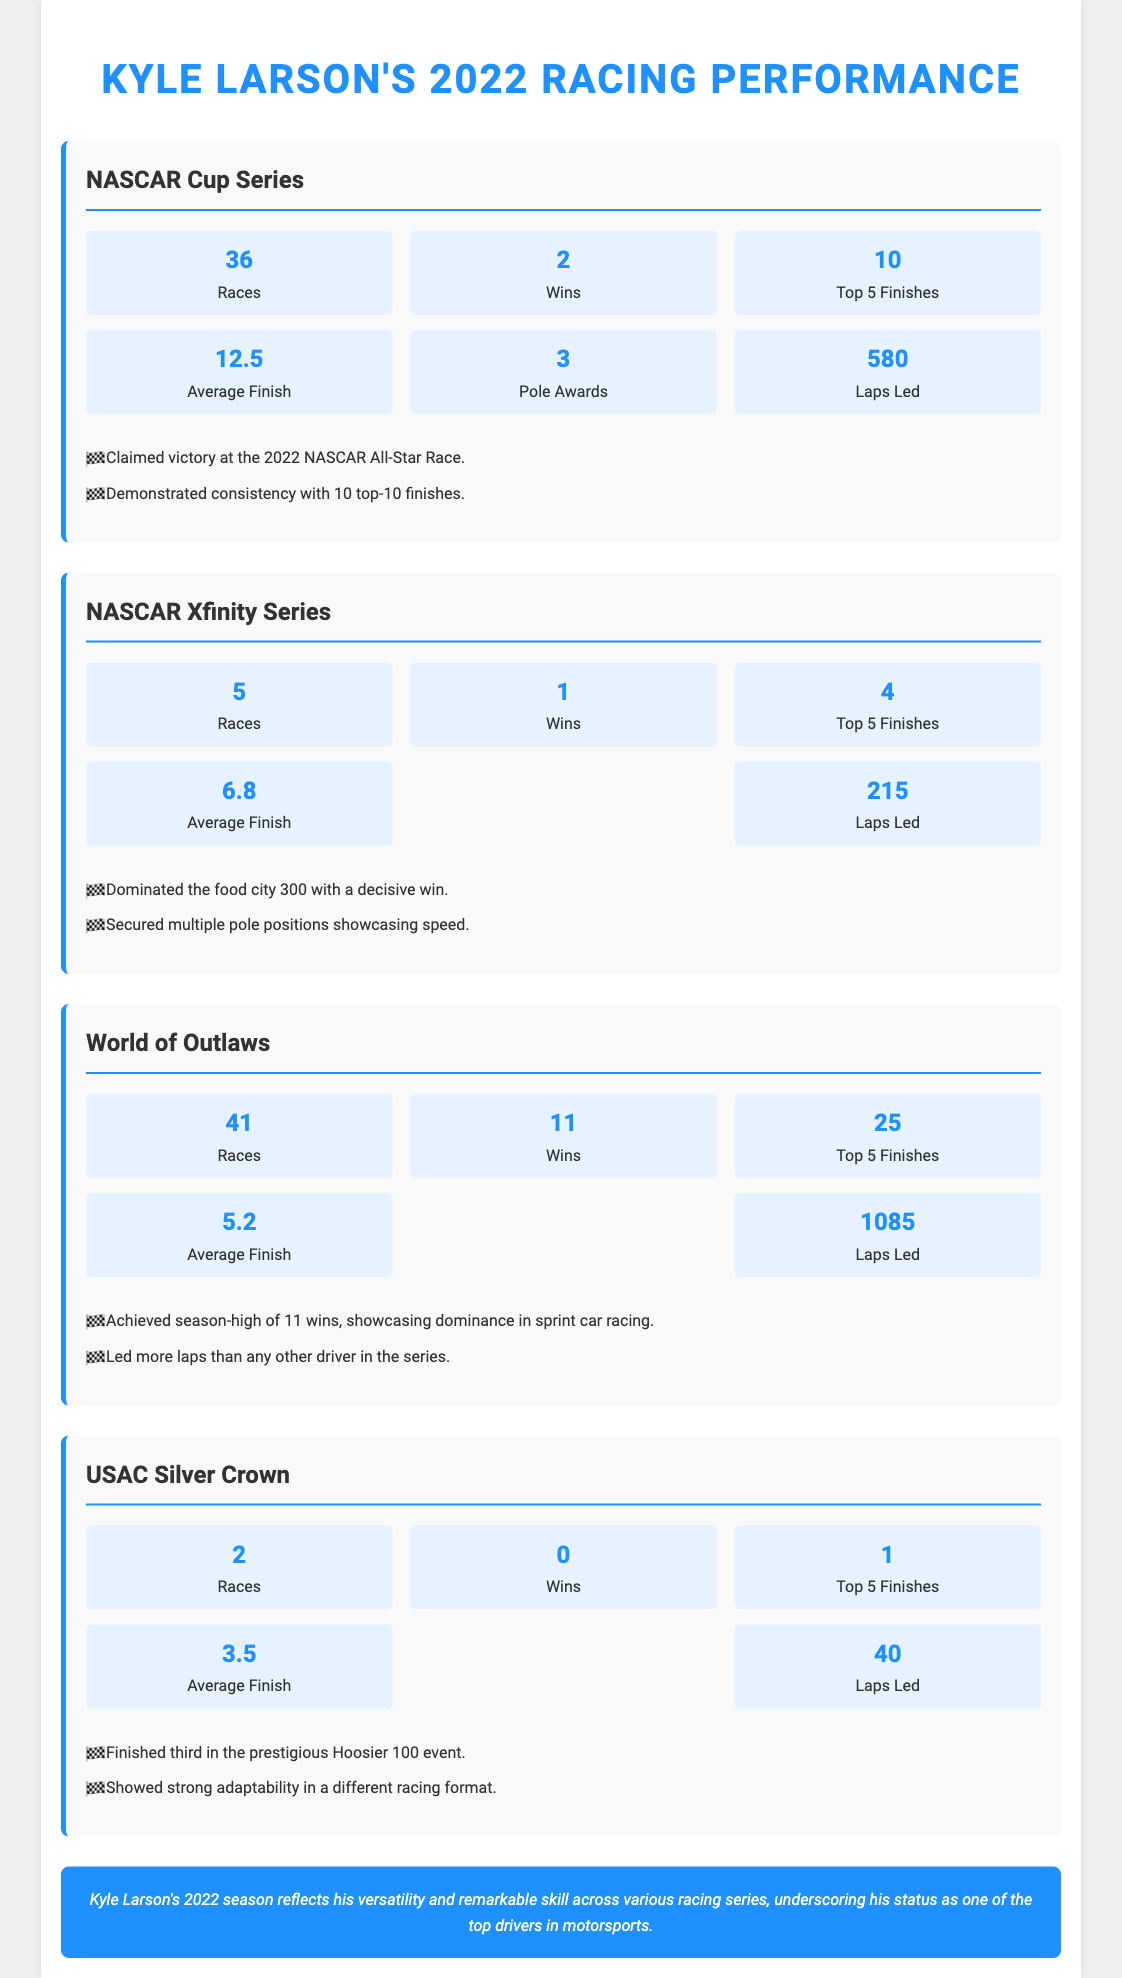What is Kyle Larson's average finish in the NASCAR Cup Series? The average finish in the NASCAR Cup Series is noted in the statistics section of that section.
Answer: 12.5 How many races did Kyle Larson participate in the World of Outlaws? The number of races is listed under the World of Outlaws section, indicating his participation.
Answer: 41 What was Kyle Larson's win count in the NASCAR Xfinity Series? The number of wins in the NASCAR Xfinity Series is specified in the respective section.
Answer: 1 In which event did Kyle Larson finish third in the USAC Silver Crown? The specific event he finished third in is mentioned in the highlights of the USAC Silver Crown section.
Answer: Hoosier 100 How many total wins did Kyle Larson achieve across all series in 2022? To find the total wins, we sum his wins from all series: 2 (NASCAR Cup) + 1 (Xfinity) + 11 (World of Outlaws) + 0 (USAC Silver Crown) equals a total.
Answer: 14 What is the average finish of Kyle Larson in World of Outlaws? Average finish is listed in the statistics section dedicated to the World of Outlaws.
Answer: 5.2 How many laps did Kyle Larson lead in the NASCAR Xfinity Series? The number of laps led in the NASCAR Xfinity Series is included in that section's statistics.
Answer: 215 What notable highlight did Kyle Larson achieve in the World of Outlaws? Achievements in the World of Outlaws are outlined in the highlights, explaining his performance.
Answer: 11 wins 